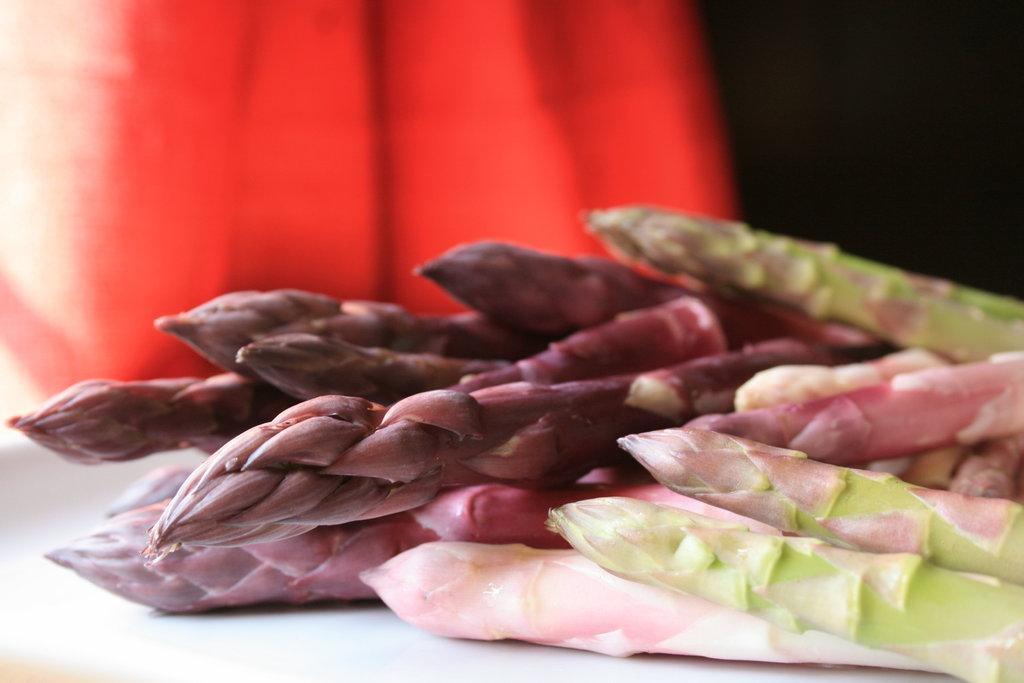In one or two sentences, can you explain what this image depicts? In this image we can see some plants are placed here. The background of the image is blurred, which is in red color. 